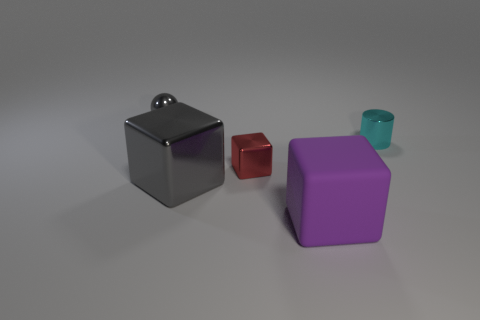What number of big objects have the same color as the small shiny sphere?
Provide a succinct answer. 1. There is a metal thing on the left side of the big metal thing; is it the same color as the big metal cube?
Offer a terse response. Yes. What number of metallic objects are either big red spheres or tiny cyan objects?
Your answer should be very brief. 1. What is the thing that is to the right of the cube in front of the gray object in front of the tiny cyan shiny cylinder made of?
Provide a succinct answer. Metal. There is a big object that is to the left of the big purple matte block; is it the same shape as the large object on the right side of the red metallic object?
Offer a very short reply. Yes. What color is the tiny object behind the object on the right side of the large purple matte block?
Offer a terse response. Gray. What number of balls are large things or small green things?
Your answer should be very brief. 0. What number of objects are behind the block to the left of the metallic block that is behind the large shiny block?
Keep it short and to the point. 3. What size is the object that is the same color as the tiny ball?
Provide a succinct answer. Large. Is there a large brown cube that has the same material as the large gray cube?
Provide a succinct answer. No. 